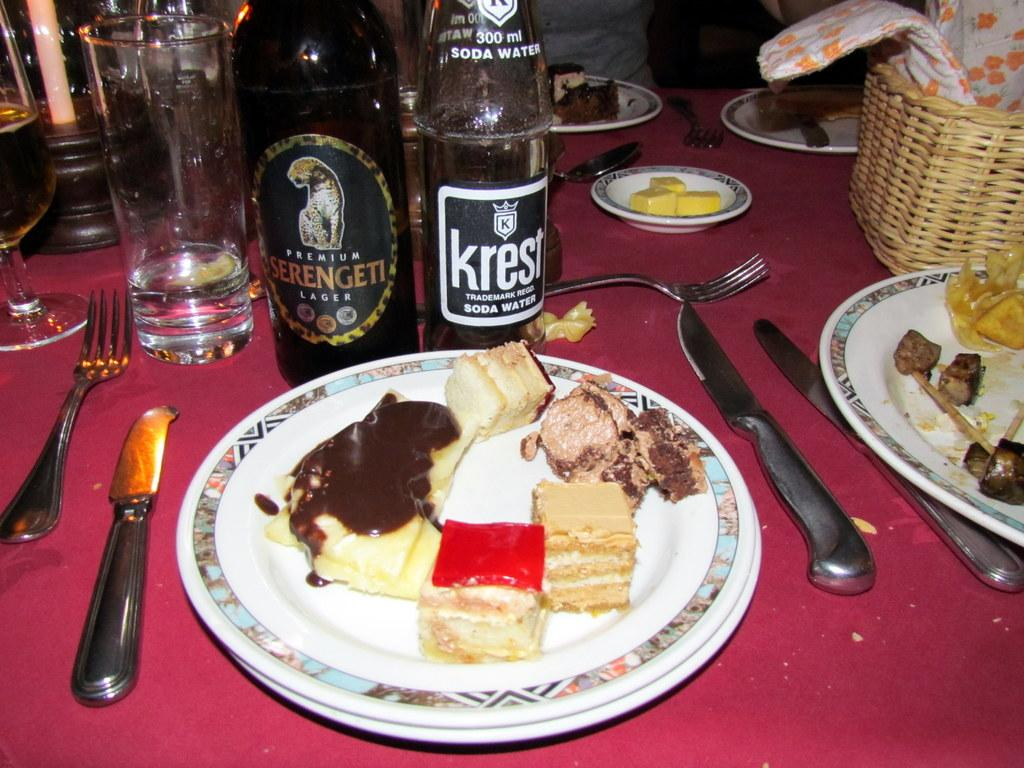Provide a one-sentence caption for the provided image. Bottle that says KREST in front of a plate of food. 